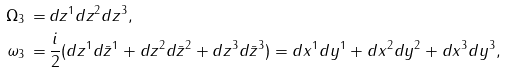Convert formula to latex. <formula><loc_0><loc_0><loc_500><loc_500>\Omega _ { 3 } \, = \, & d z ^ { 1 } d z ^ { 2 } d z ^ { 3 } , \\ \omega _ { 3 } \, = \, & \frac { i } { 2 } ( d z ^ { 1 } d \bar { z } ^ { 1 } + d z ^ { 2 } d \bar { z } ^ { 2 } + d z ^ { 3 } d \bar { z } ^ { 3 } ) = d x ^ { 1 } d y ^ { 1 } + d x ^ { 2 } d y ^ { 2 } + d x ^ { 3 } d y ^ { 3 } ,</formula> 